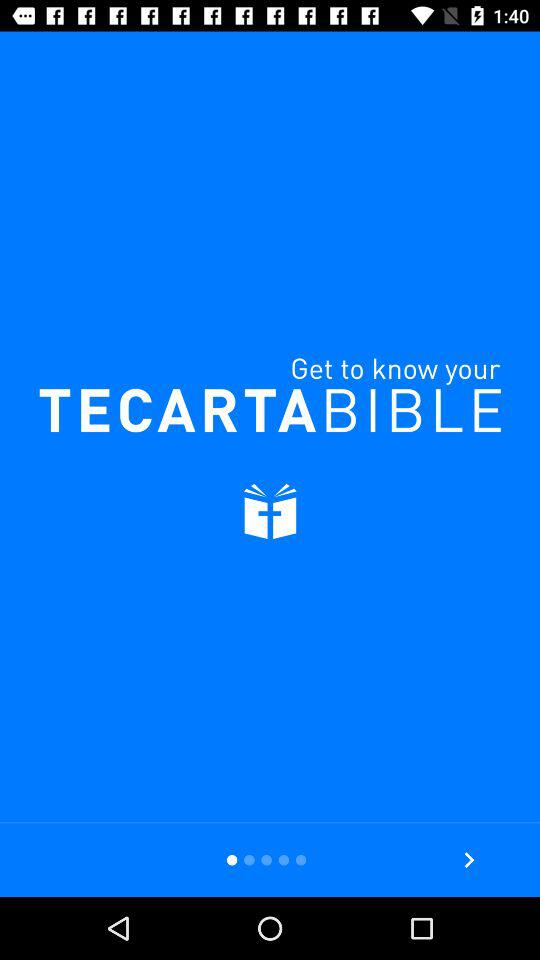What is the application name? The application is "TECARTABIBLE". 